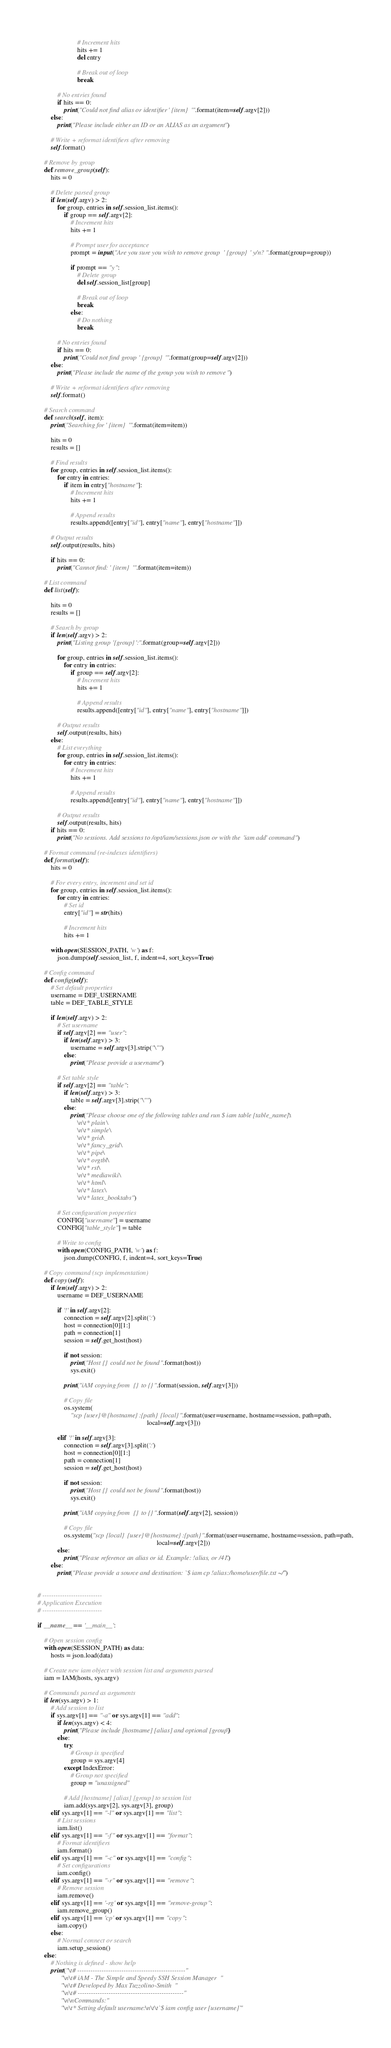<code> <loc_0><loc_0><loc_500><loc_500><_Python_>                        # Increment hits
                        hits += 1
                        del entry

                        # Break out of loop
                        break

            # No entries found
            if hits == 0:
                print("Could not find alias or identifier ' {item} '".format(item=self.argv[2]))
        else:
            print("Please include either an ID or an ALIAS as an argument")

        # Write + reformat identifiers after removing
        self.format()

    # Remove by group
    def remove_group(self):
        hits = 0

        # Delete parsed group
        if len(self.argv) > 2:
            for group, entries in self.session_list.items():
                if group == self.argv[2]:
                    # Increment hits
                    hits += 1

                    # Prompt user for acceptance
                    prompt = input("Are you sure you wish to remove group ' {group} ' y/n? ".format(group=group))

                    if prompt == "y":
                        # Delete group
                        del self.session_list[group]

                        # Break out of loop
                        break
                    else:
                        # Do nothing
                        break

            # No entries found
            if hits == 0:
                print("Could not find group ' {group} '".format(group=self.argv[2]))
        else:
            print("Please include the name of the group you wish to remove")

        # Write + reformat identifiers after removing
        self.format()

    # Search command
    def search(self, item):
        print("Searching for ' {item} '".format(item=item))

        hits = 0
        results = []

        # Find results
        for group, entries in self.session_list.items():
            for entry in entries:
                if item in entry["hostname"]:
                    # Increment hits
                    hits += 1

                    # Append results
                    results.append([entry["id"], entry["name"], entry["hostname"]])

        # Output results
        self.output(results, hits)

        if hits == 0:
            print("Cannot find: ' {item} '".format(item=item))

    # List command
    def list(self):

        hits = 0
        results = []

        # Search by group
        if len(self.argv) > 2:
            print("Listing group '{group}':".format(group=self.argv[2]))

            for group, entries in self.session_list.items():
                for entry in entries:
                    if group == self.argv[2]:
                        # Increment hits
                        hits += 1

                        # Append results
                        results.append([entry["id"], entry["name"], entry["hostname"]])

            # Output results
            self.output(results, hits)
        else:
            # List everything
            for group, entries in self.session_list.items():
                for entry in entries:
                    # Increment hits
                    hits += 1

                    # Append results
                    results.append([entry["id"], entry["name"], entry["hostname"]])

            # Output results
            self.output(results, hits)
        if hits == 0:
            print("No sessions. Add sessions to /opt/iam/sessions.json or with the 'iam add' command")

    # Format command (re-indexes identifiers)
    def format(self):
        hits = 0

        # For every entry, increment and set id
        for group, entries in self.session_list.items():
            for entry in entries:
                # Set id
                entry["id"] = str(hits)

                # Increment hits
                hits += 1

        with open(SESSION_PATH, 'w') as f:
            json.dump(self.session_list, f, indent=4, sort_keys=True)

    # Config command
    def config(self):
        # Set default properties
        username = DEF_USERNAME
        table = DEF_TABLE_STYLE

        if len(self.argv) > 2:
            # Set username
            if self.argv[2] == "user":
                if len(self.argv) > 3:
                    username = self.argv[3].strip("\"")
                else:
                    print("Please provide a username")

            # Set table style
            if self.argv[2] == "table":
                if len(self.argv) > 3:
                    table = self.argv[3].strip("\"")
                else:
                    print("Please choose one of the following tables and run $ iam table [table_name]:\
                        \n\t* plain \
                        \n\t* simple\
                        \n\t* grid\
                        \n\t* fancy_grid\
                        \n\t* pipe\
                        \n\t* orgtbl\
                        \n\t* rst\
                        \n\t* mediawiki\
                        \n\t* html\
                        \n\t* latex\
                        \n\t* latex_booktabs")

            # Set configuration properties
            CONFIG["username"] = username
            CONFIG["table_style"] = table

            # Write to config
            with open(CONFIG_PATH, 'w') as f:
                json.dump(CONFIG, f, indent=4, sort_keys=True)

    # Copy command (scp implementation)
    def copy(self):
        if len(self.argv) > 2:
            username = DEF_USERNAME

            if '!' in self.argv[2]:
                connection = self.argv[2].split(':')
                host = connection[0][1:]
                path = connection[1]
                session = self.get_host(host)

                if not session:
                    print("Host {} could not be found".format(host))
                    sys.exit()

                print("iAM copying from {} to {}".format(session, self.argv[3]))

                # Copy file
                os.system(
                    "scp {user}@{hostname}:{path} {local}".format(user=username, hostname=session, path=path,
                                                                  local=self.argv[3]))

            elif '!' in self.argv[3]:
                connection = self.argv[3].split(':')
                host = connection[0][1:]
                path = connection[1]
                session = self.get_host(host)

                if not session:
                    print("Host {} could not be found".format(host))
                    sys.exit()

                print("iAM copying from {} to {}".format(self.argv[2], session))

                # Copy file
                os.system("scp {local} {user}@{hostname}:{path}".format(user=username, hostname=session, path=path,
                                                                        local=self.argv[2]))
            else:
                print("Please reference an alias or id. Example: !alias, or /41.")
        else:
            print("Please provide a source and destination: `$ iam cp !alias:/home/user/file.txt ~/`")


# ---------------------------
# Application Execution
# ---------------------------

if __name__ == '__main__':

    # Open session config
    with open(SESSION_PATH) as data:
        hosts = json.load(data)

    # Create new iam object with session list and arguments parsed
    iam = IAM(hosts, sys.argv)

    # Commands parsed as arguments
    if len(sys.argv) > 1:
        # Add session to list
        if sys.argv[1] == "-a" or sys.argv[1] == "add":
            if len(sys.argv) < 4:
                print("Please include [hostname] [alias] and optional [group]")
            else:
                try:
                    # Group is specified
                    group = sys.argv[4]
                except IndexError:
                    # Group not specified
                    group = "unassigned"

                # Add [hostname] [alias] [group] to session list
                iam.add(sys.argv[2], sys.argv[3], group)
        elif sys.argv[1] == "-l" or sys.argv[1] == "list":
            # List sessions
            iam.list()
        elif sys.argv[1] == "-f" or sys.argv[1] == "format":
            # Format identifiers
            iam.format()
        elif sys.argv[1] == "-c" or sys.argv[1] == "config":
            # Set configurations
            iam.config()
        elif sys.argv[1] == "-r" or sys.argv[1] == "remove":
            # Remove session
            iam.remove()
        elif sys.argv[1] == '-rg' or sys.argv[1] == "remove-group":
            iam.remove_group()
        elif sys.argv[1] == 'cp' or sys.argv[1] == "copy":
            iam.copy()
        else:
            # Normal connect or search
            iam.setup_session()
    else:
        # Nothing is defined - show help
        print("\t# -------------------------------------------------"
              "\n\t# iAM - The Simple and Speedy SSH Session Manager"
              "\n\t# Developed by Max Tuzzolino-Smith"
              "\n\t# ------------------------------------------------"
              "\n\nCommands:"
              "\n\t* Setting default username:\n\t\t`$ iam config user [username]`"</code> 